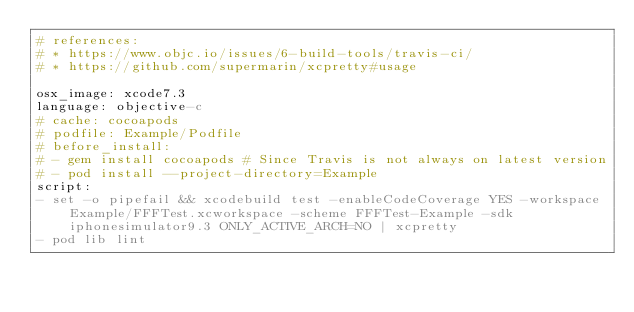<code> <loc_0><loc_0><loc_500><loc_500><_YAML_># references:
# * https://www.objc.io/issues/6-build-tools/travis-ci/
# * https://github.com/supermarin/xcpretty#usage

osx_image: xcode7.3
language: objective-c
# cache: cocoapods
# podfile: Example/Podfile
# before_install:
# - gem install cocoapods # Since Travis is not always on latest version
# - pod install --project-directory=Example
script:
- set -o pipefail && xcodebuild test -enableCodeCoverage YES -workspace Example/FFFTest.xcworkspace -scheme FFFTest-Example -sdk iphonesimulator9.3 ONLY_ACTIVE_ARCH=NO | xcpretty
- pod lib lint
</code> 